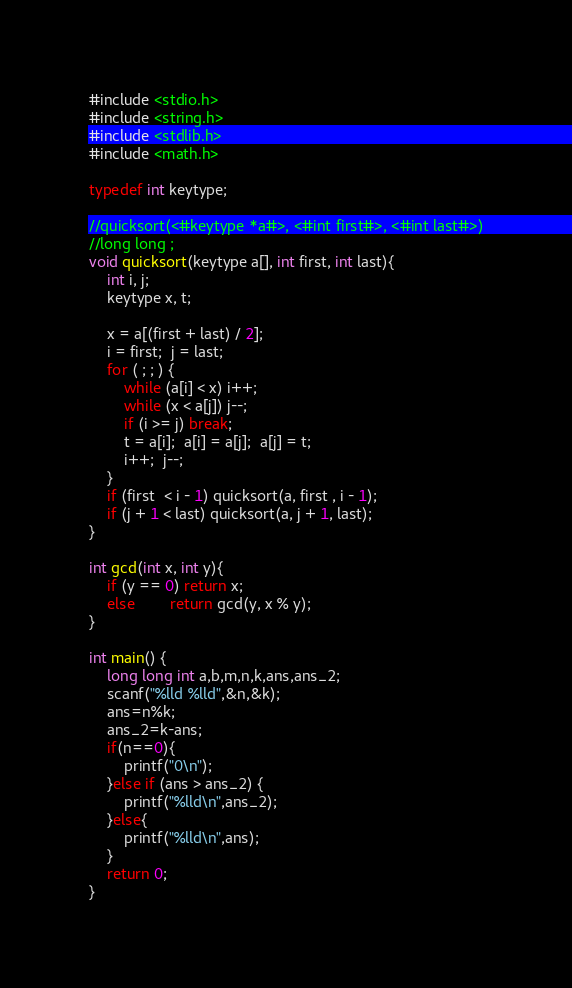<code> <loc_0><loc_0><loc_500><loc_500><_C_>#include <stdio.h>
#include <string.h>
#include <stdlib.h>
#include <math.h>

typedef int keytype;

//quicksort(<#keytype *a#>, <#int first#>, <#int last#>)
//long long ;
void quicksort(keytype a[], int first, int last){
    int i, j;
    keytype x, t;
    
    x = a[(first + last) / 2];
    i = first;  j = last;
    for ( ; ; ) {
        while (a[i] < x) i++;
        while (x < a[j]) j--;
        if (i >= j) break;
        t = a[i];  a[i] = a[j];  a[j] = t;
        i++;  j--;
    }
    if (first  < i - 1) quicksort(a, first , i - 1);
    if (j + 1 < last) quicksort(a, j + 1, last);
}

int gcd(int x, int y){
    if (y == 0) return x;
    else        return gcd(y, x % y);
}

int main() {
    long long int a,b,m,n,k,ans,ans_2;
    scanf("%lld %lld",&n,&k);
    ans=n%k;
    ans_2=k-ans;
    if(n==0){
        printf("0\n");
    }else if (ans > ans_2) {
        printf("%lld\n",ans_2);
    }else{
        printf("%lld\n",ans);
    }
    return 0;
}
</code> 